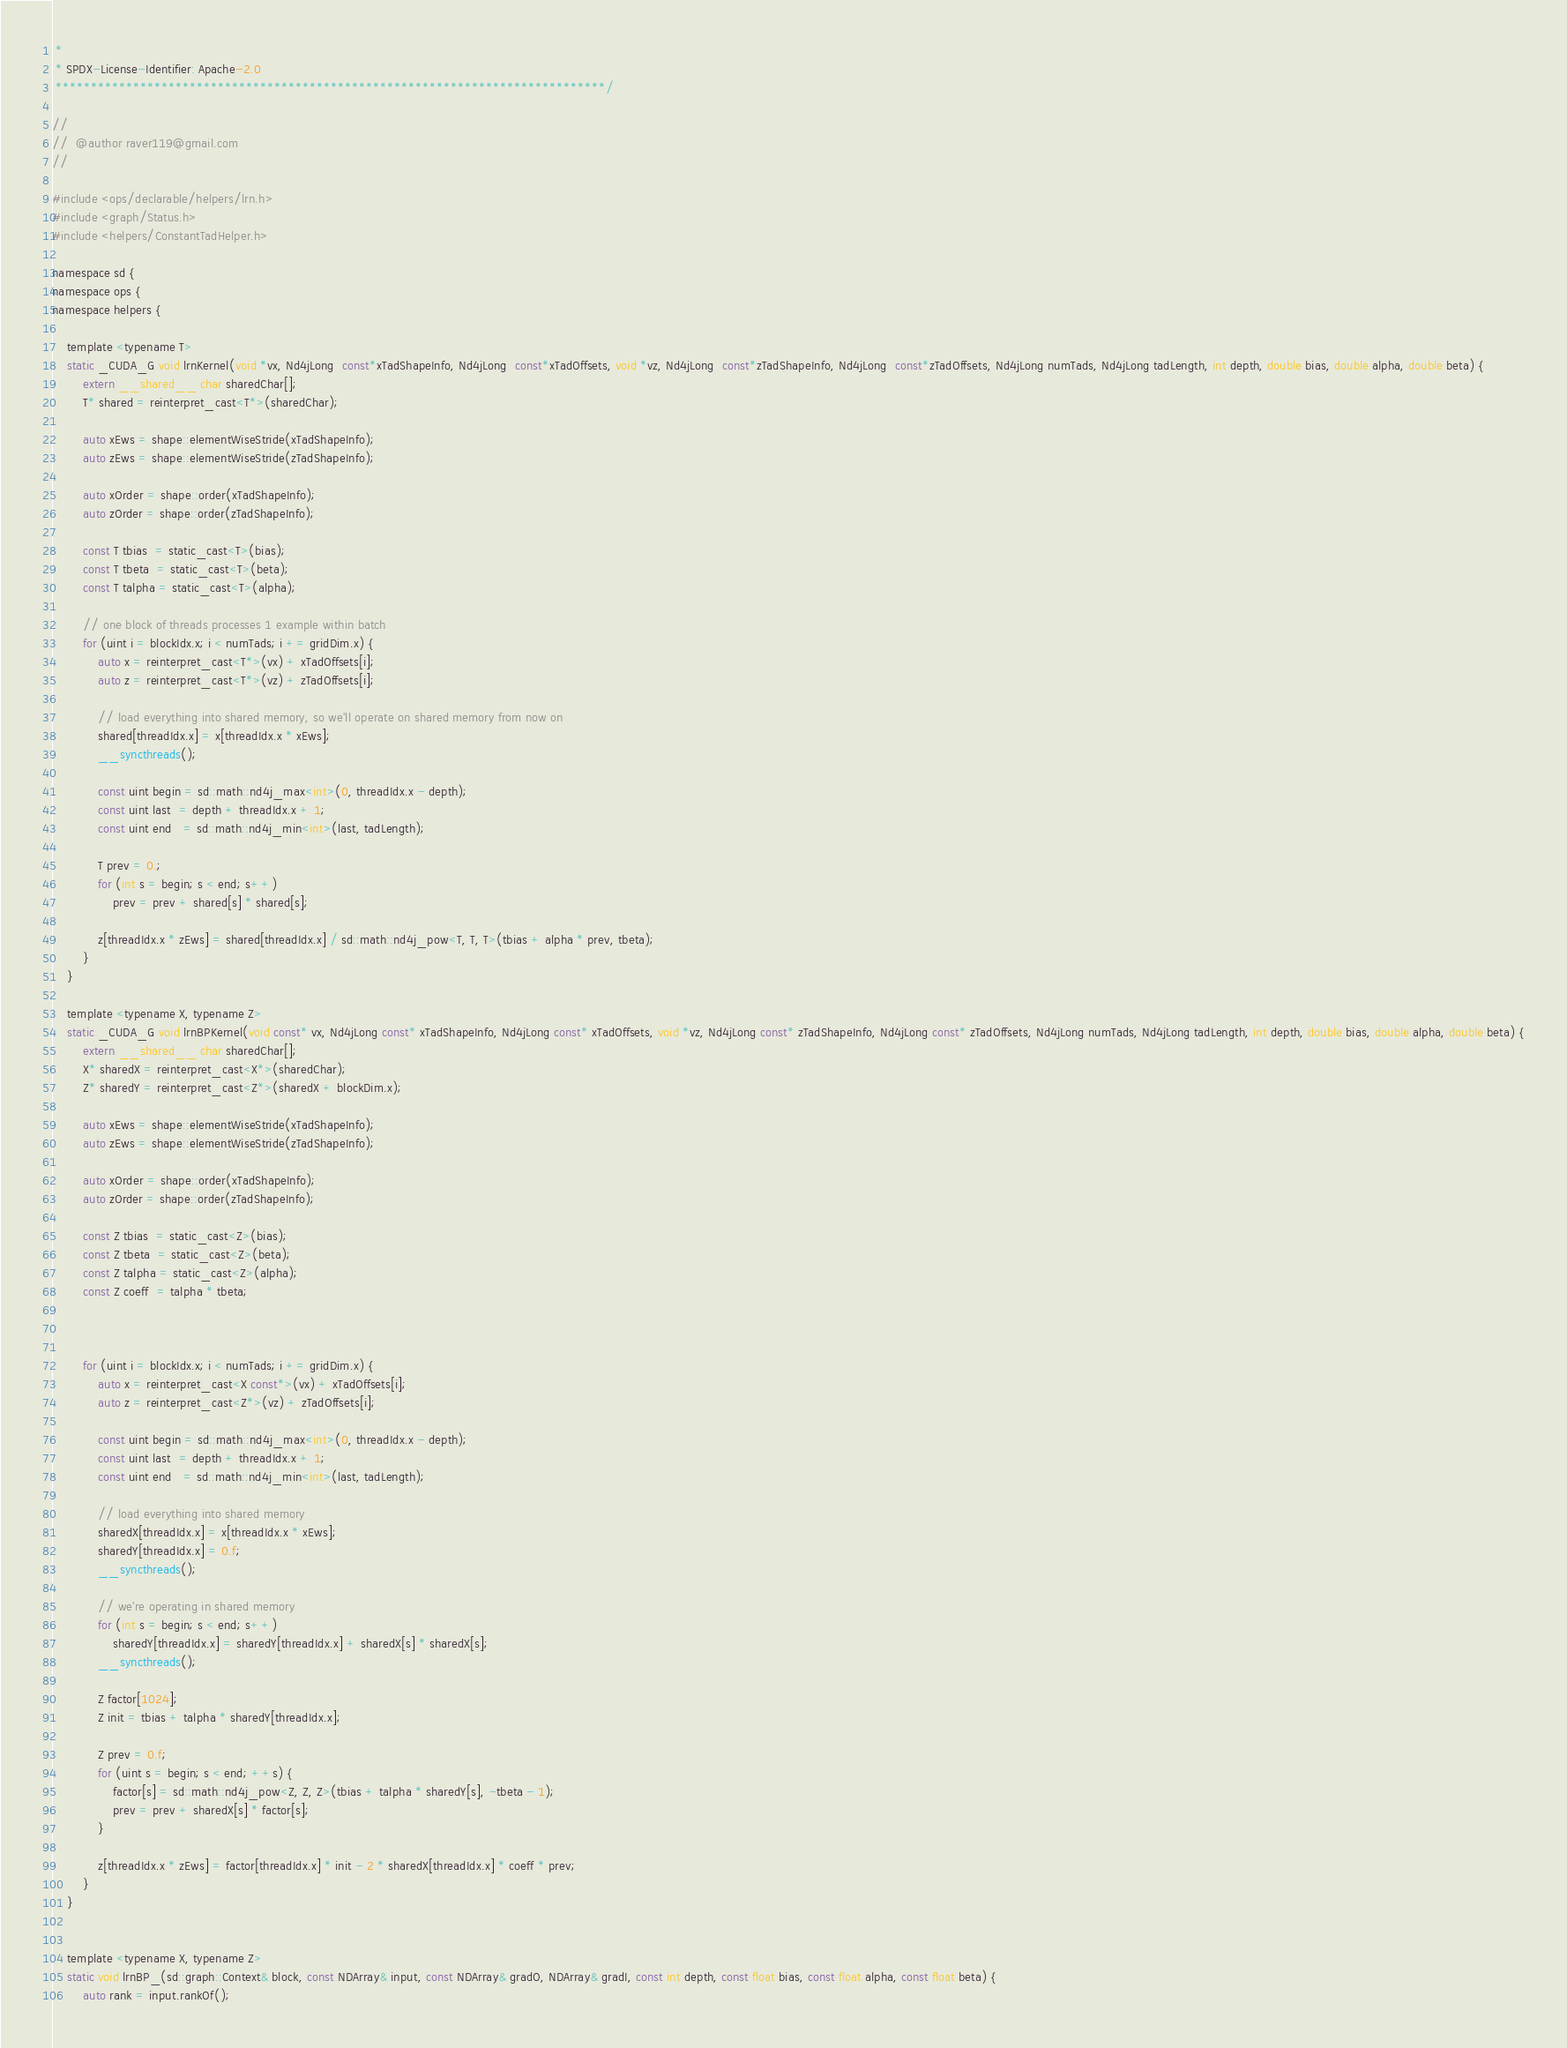<code> <loc_0><loc_0><loc_500><loc_500><_Cuda_> *
 * SPDX-License-Identifier: Apache-2.0
 ******************************************************************************/

//
//  @author raver119@gmail.com
//

#include <ops/declarable/helpers/lrn.h>
#include <graph/Status.h>
#include <helpers/ConstantTadHelper.h>

namespace sd {
namespace ops {
namespace helpers {

    template <typename T>
    static _CUDA_G void lrnKernel(void *vx, Nd4jLong  const*xTadShapeInfo, Nd4jLong  const*xTadOffsets, void *vz, Nd4jLong  const*zTadShapeInfo, Nd4jLong  const*zTadOffsets, Nd4jLong numTads, Nd4jLong tadLength, int depth, double bias, double alpha, double beta) {
        extern __shared__ char sharedChar[];
        T* shared = reinterpret_cast<T*>(sharedChar);

        auto xEws = shape::elementWiseStride(xTadShapeInfo);
        auto zEws = shape::elementWiseStride(zTadShapeInfo);

        auto xOrder = shape::order(xTadShapeInfo);
        auto zOrder = shape::order(zTadShapeInfo);

        const T tbias  = static_cast<T>(bias);
        const T tbeta  = static_cast<T>(beta);
        const T talpha = static_cast<T>(alpha);

        // one block of threads processes 1 example within batch
        for (uint i = blockIdx.x; i < numTads; i += gridDim.x) {
            auto x = reinterpret_cast<T*>(vx) + xTadOffsets[i];
            auto z = reinterpret_cast<T*>(vz) + zTadOffsets[i];

            // load everything into shared memory, so we'll operate on shared memory from now on
            shared[threadIdx.x] = x[threadIdx.x * xEws];
            __syncthreads();

            const uint begin = sd::math::nd4j_max<int>(0, threadIdx.x - depth);
            const uint last  = depth + threadIdx.x + 1;
            const uint end   = sd::math::nd4j_min<int>(last, tadLength);

            T prev = 0.;
            for (int s = begin; s < end; s++)
                prev = prev + shared[s] * shared[s];

            z[threadIdx.x * zEws] = shared[threadIdx.x] / sd::math::nd4j_pow<T, T, T>(tbias + alpha * prev, tbeta);
        }
    }

    template <typename X, typename Z>
    static _CUDA_G void lrnBPKernel(void const* vx, Nd4jLong const* xTadShapeInfo, Nd4jLong const* xTadOffsets, void *vz, Nd4jLong const* zTadShapeInfo, Nd4jLong const* zTadOffsets, Nd4jLong numTads, Nd4jLong tadLength, int depth, double bias, double alpha, double beta) {
        extern __shared__ char sharedChar[];
        X* sharedX = reinterpret_cast<X*>(sharedChar);
        Z* sharedY = reinterpret_cast<Z*>(sharedX + blockDim.x);

        auto xEws = shape::elementWiseStride(xTadShapeInfo);
        auto zEws = shape::elementWiseStride(zTadShapeInfo);

        auto xOrder = shape::order(xTadShapeInfo);
        auto zOrder = shape::order(zTadShapeInfo);

        const Z tbias  = static_cast<Z>(bias);
        const Z tbeta  = static_cast<Z>(beta);
        const Z talpha = static_cast<Z>(alpha);
        const Z coeff  = talpha * tbeta;



        for (uint i = blockIdx.x; i < numTads; i += gridDim.x) {
            auto x = reinterpret_cast<X const*>(vx) + xTadOffsets[i];
            auto z = reinterpret_cast<Z*>(vz) + zTadOffsets[i];

            const uint begin = sd::math::nd4j_max<int>(0, threadIdx.x - depth);
            const uint last  = depth + threadIdx.x + 1;
            const uint end   = sd::math::nd4j_min<int>(last, tadLength);

            // load everything into shared memory
            sharedX[threadIdx.x] = x[threadIdx.x * xEws];
            sharedY[threadIdx.x] = 0.f;
            __syncthreads();

            // we're operating in shared memory
            for (int s = begin; s < end; s++)
                sharedY[threadIdx.x] = sharedY[threadIdx.x] + sharedX[s] * sharedX[s];
            __syncthreads();

            Z factor[1024];
            Z init = tbias + talpha * sharedY[threadIdx.x];

            Z prev = 0.f;
            for (uint s = begin; s < end; ++s) {
                factor[s] = sd::math::nd4j_pow<Z, Z, Z>(tbias + talpha * sharedY[s], -tbeta - 1);
                prev = prev + sharedX[s] * factor[s];
            }

            z[threadIdx.x * zEws] = factor[threadIdx.x] * init - 2 * sharedX[threadIdx.x] * coeff * prev;
        }
    }


    template <typename X, typename Z>
    static void lrnBP_(sd::graph::Context& block, const NDArray& input, const NDArray& gradO, NDArray& gradI, const int depth, const float bias, const float alpha, const float beta) {
        auto rank = input.rankOf();</code> 